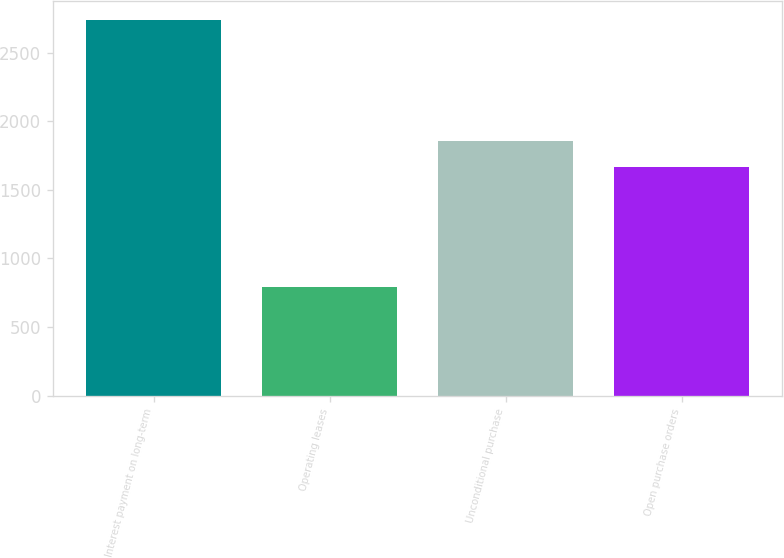Convert chart to OTSL. <chart><loc_0><loc_0><loc_500><loc_500><bar_chart><fcel>Interest payment on long-term<fcel>Operating leases<fcel>Unconditional purchase<fcel>Open purchase orders<nl><fcel>2741<fcel>789<fcel>1860.2<fcel>1665<nl></chart> 